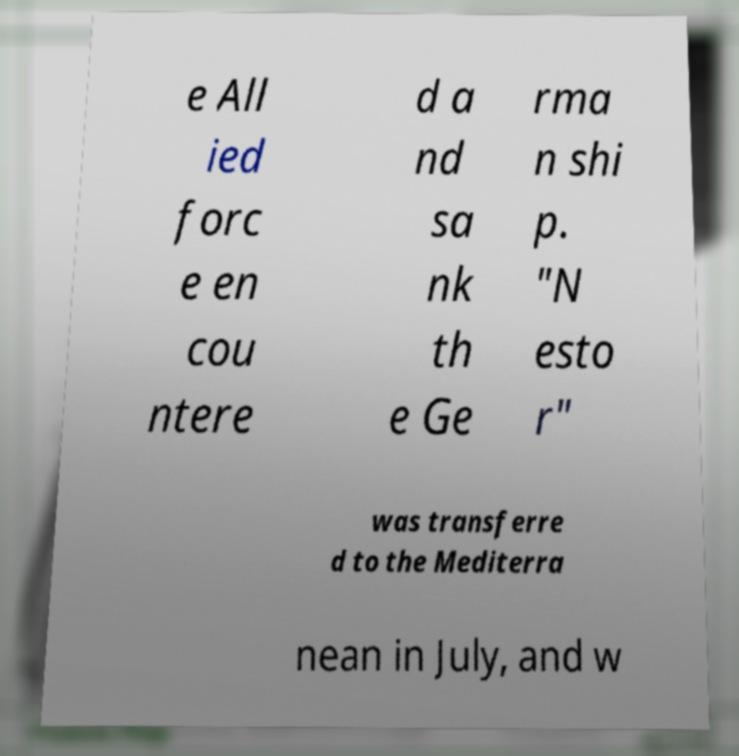I need the written content from this picture converted into text. Can you do that? e All ied forc e en cou ntere d a nd sa nk th e Ge rma n shi p. "N esto r" was transferre d to the Mediterra nean in July, and w 